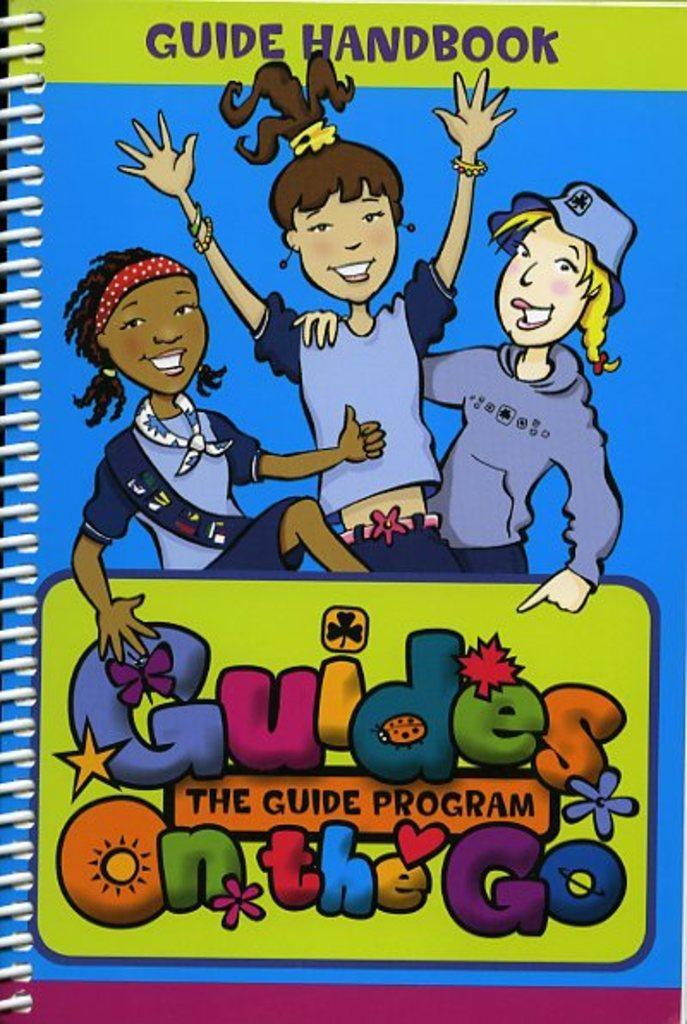In one or two sentences, can you explain what this image depicts? In this image I can see the cover page of a book which is blue and green in color. On the cover page I can see three children smiling and few words written. 